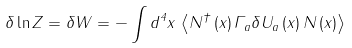<formula> <loc_0><loc_0><loc_500><loc_500>\delta \ln Z = \delta W = - \int d ^ { 4 } x \, \left \langle N ^ { \dagger } \left ( x \right ) \Gamma _ { a } \delta U _ { a } \left ( x \right ) N \left ( x \right ) \right \rangle</formula> 